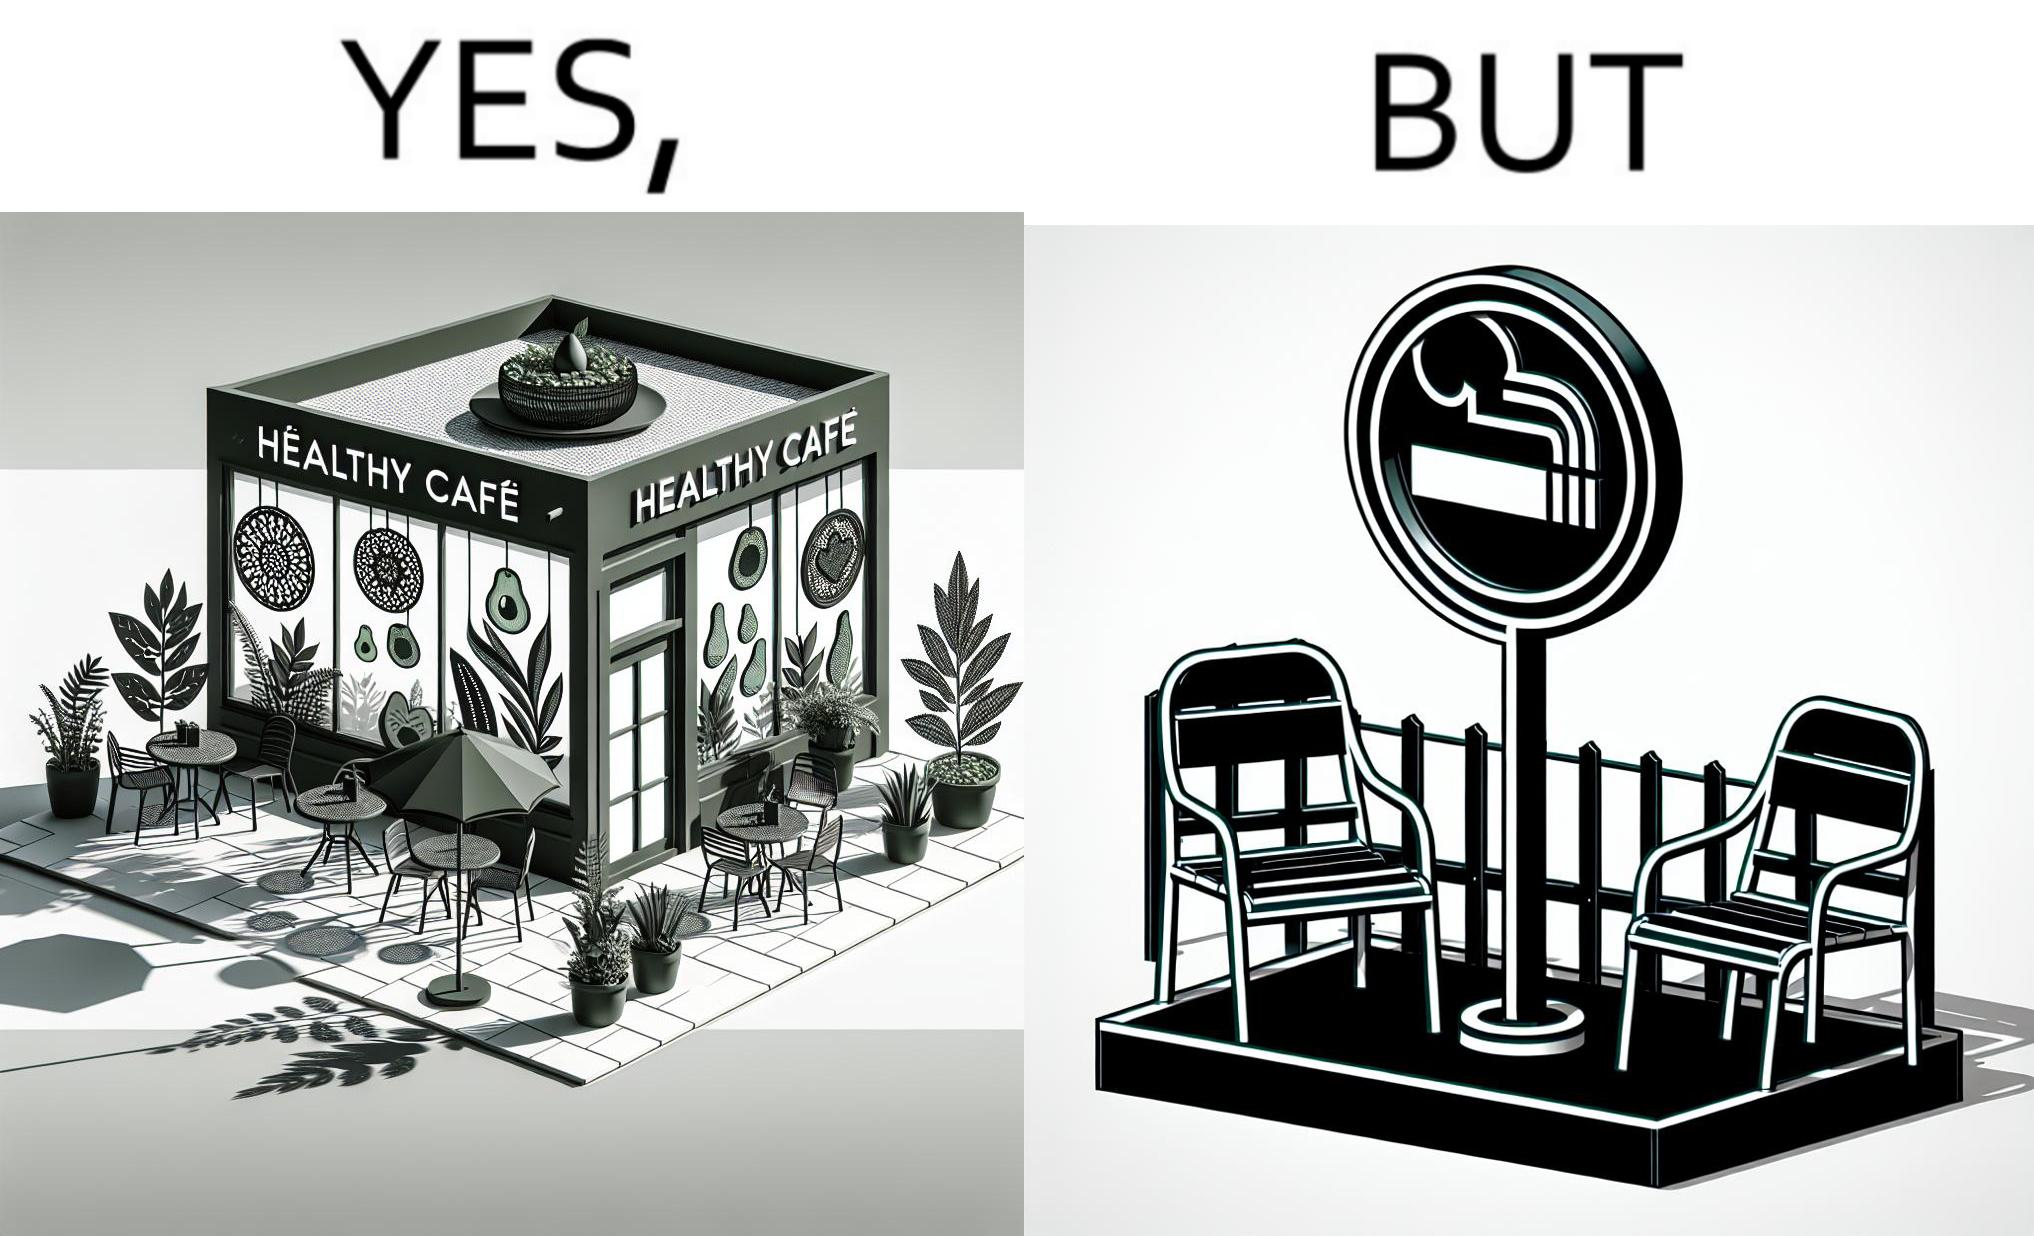Explain why this image is satirical. This image is funny because an eatery that calls itself the "healthy" cafe also has a smoking area, which is not very "healthy". If it really was a healthy cafe, it would not have a smoking area as smoking is injurious to health. Satire on the behavior of humans - both those that operate this cafe who made the decision of allowing smoking and creating a designated smoking area, and those that visit this healthy cafe to become "healthy", but then also indulge in very unhealthy habits simultaneously. 